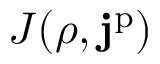Convert formula to latex. <formula><loc_0><loc_0><loc_500><loc_500>J ( \rho , j ^ { p } )</formula> 